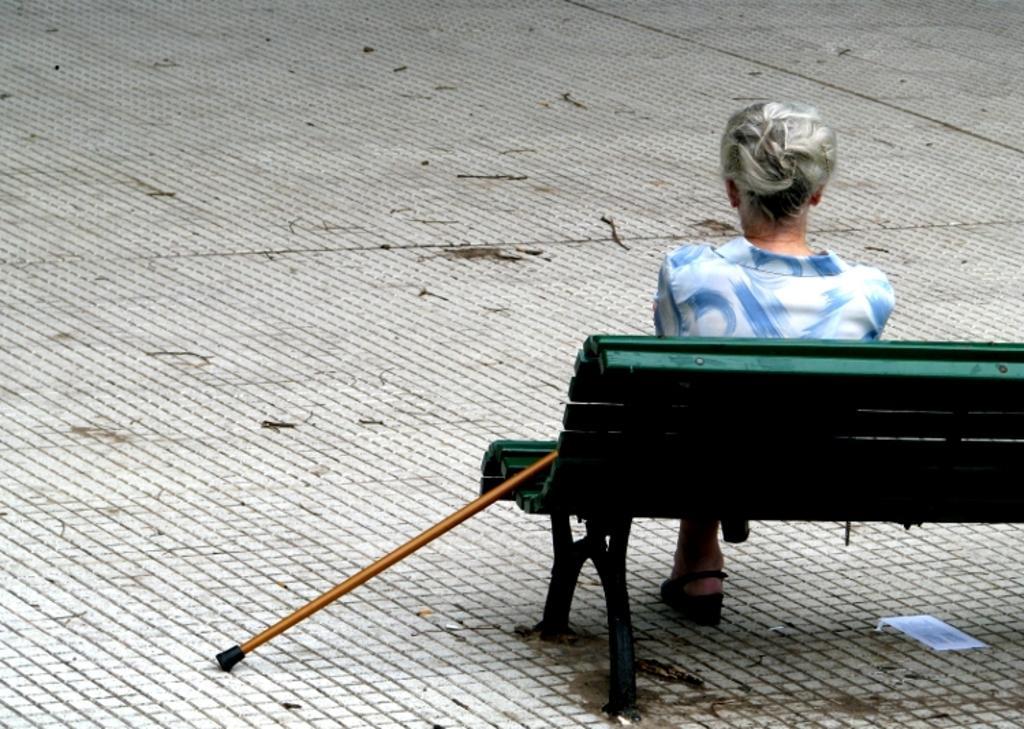Describe this image in one or two sentences. In this image we can see one bench on the floor on the right side of the image, one person sitting on the bench, one walking stick near the bench, one paper with text under the bench, some objects looks like dried sticks on the floor. 